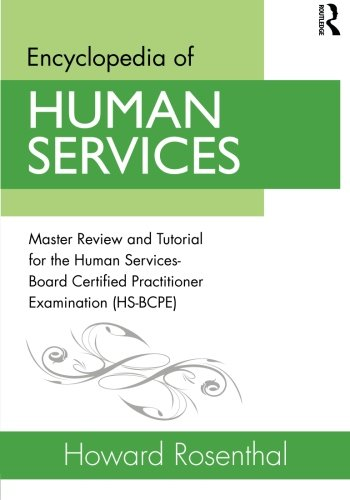Is this book related to Politics & Social Sciences? Absolutely, the book is pertinent to Politics & Social Sciences, particularly focusing on the human services domain, which encompasses social work, counseling, and community services among others. 